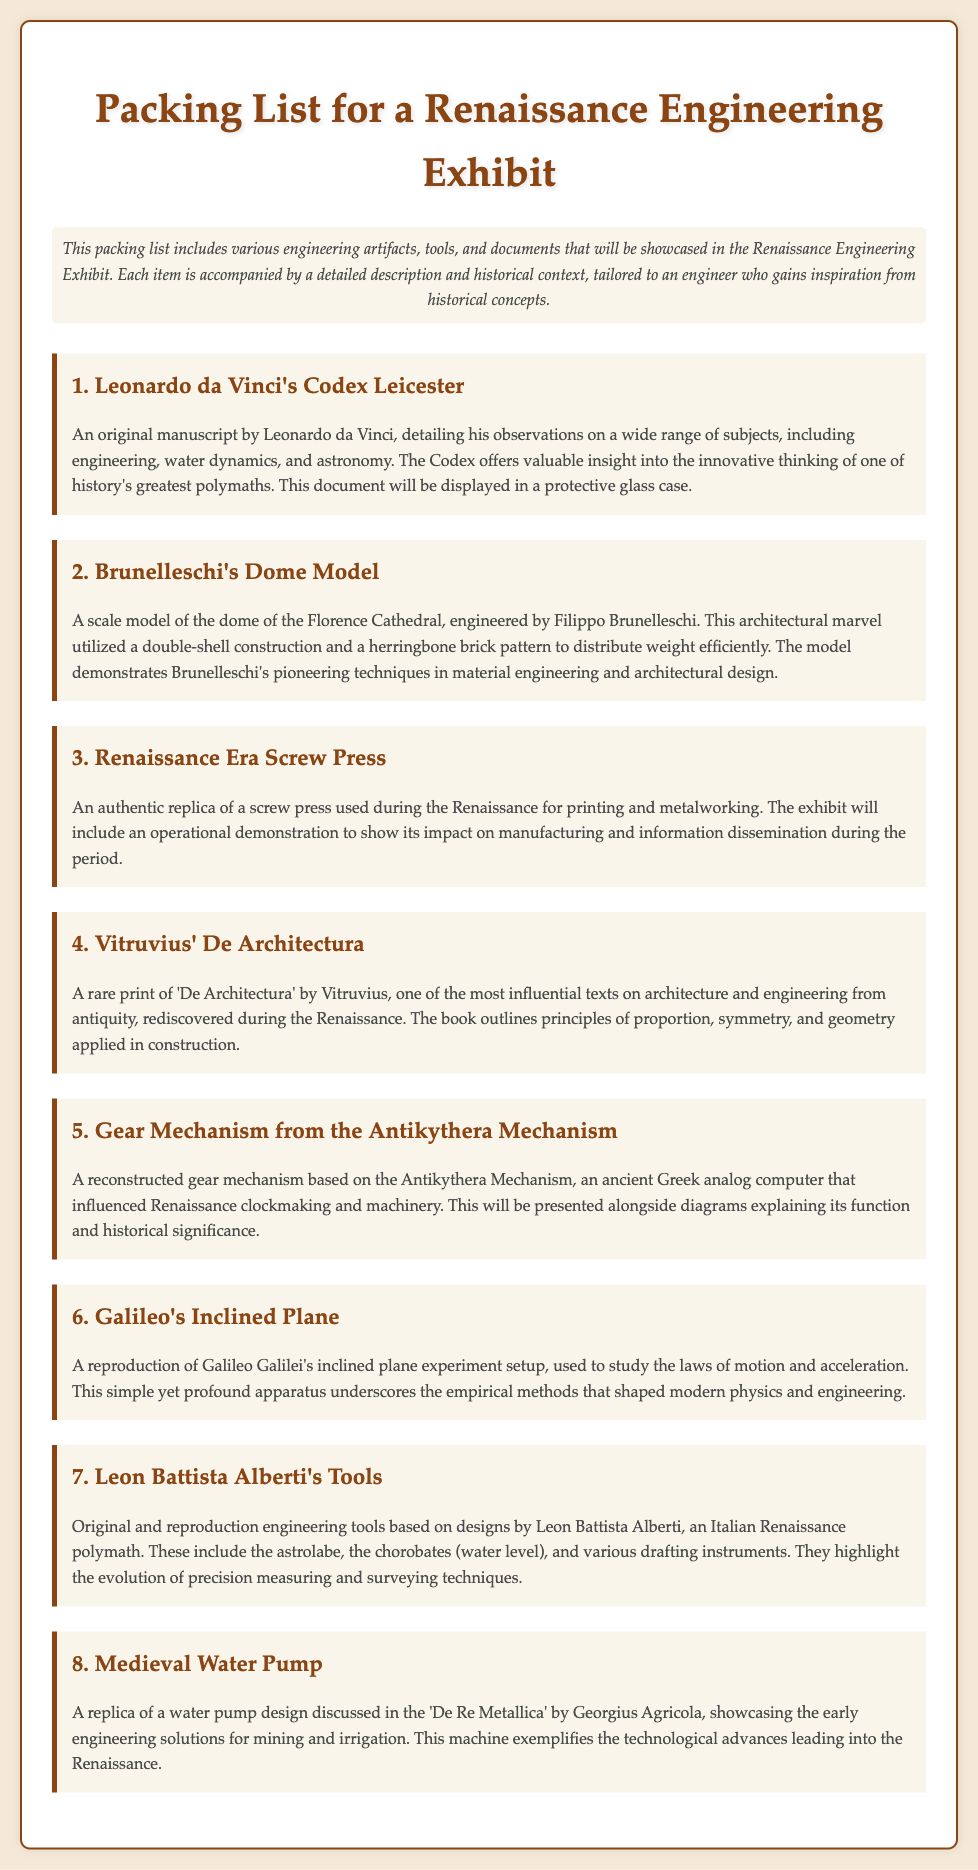What is the title of the exhibit? The title of the exhibit is found at the top of the document, presenting the main focus of the packing list.
Answer: Packing List for a Renaissance Engineering Exhibit Who created the Codex Leicester? The Codex Leicester is attributed to one of history's greatest polymaths, whose work is highlighted in the document.
Answer: Leonardo da Vinci What is the dome model a replica of? The text specifies that the model belongs to a famous architectural structure in Florence, showcasing the ingenuity of its designer.
Answer: Dome of the Florence Cathedral What does the Renaissance Era Screw Press demonstrate? The document explains the operational demonstration will illustrate the impact of this tool on a specific sector during the Renaissance.
Answer: Manufacturing and information dissemination Which famous text is mentioned for its influence on architecture? This influential text is highlighted as a significant contribution to architecture and engineering, rediscovered during the Renaissance era.
Answer: De Architectura Who influenced Renaissance clockmaking? A specific ancient Greek artifact is mentioned that had an impact on clockmaking during the Renaissance.
Answer: Antikythera Mechanism What type of tools are based on designs by Leon Battista Alberti? The packing list indicates a variety of tools that exemplify significant advancements in measuring techniques in engineering.
Answer: Engineering tools How is Galileo's inclined plane used? The document states this apparatus helped in studying fundamental principles that are critical to modern science.
Answer: Laws of motion and acceleration 